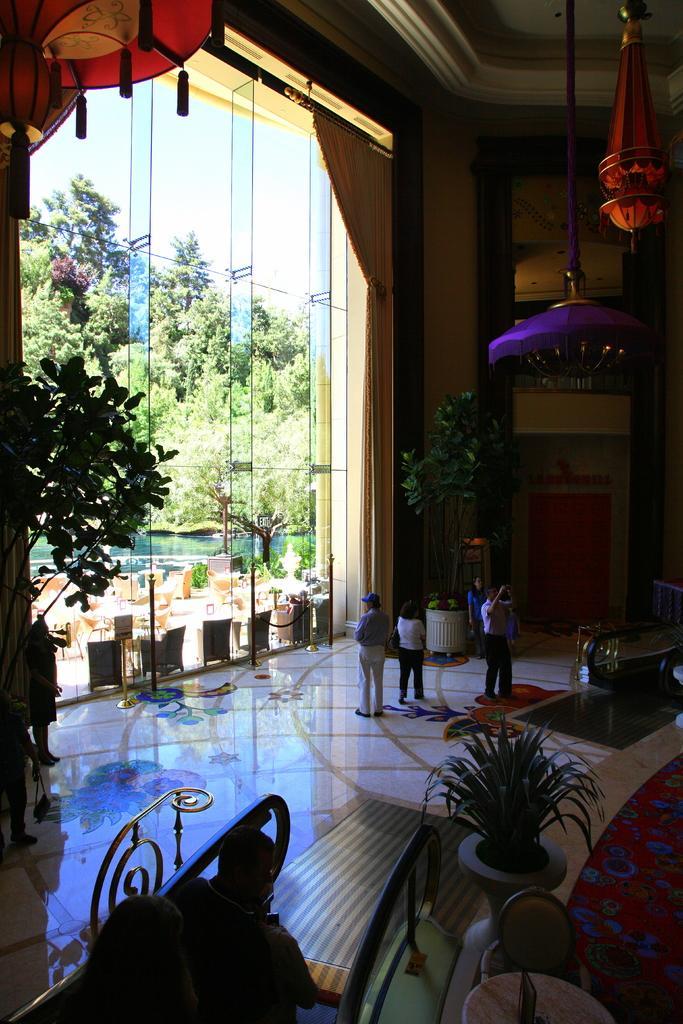Please provide a concise description of this image. In this image we can see a glass, Behind the glass table, chairs and trees are there. At the bottom of the image plant, railing, table and chair are there. At the top of the image we can see chandeliers are attached to the roof. In the middle of the image one plant is there and people are standing on the floor. 